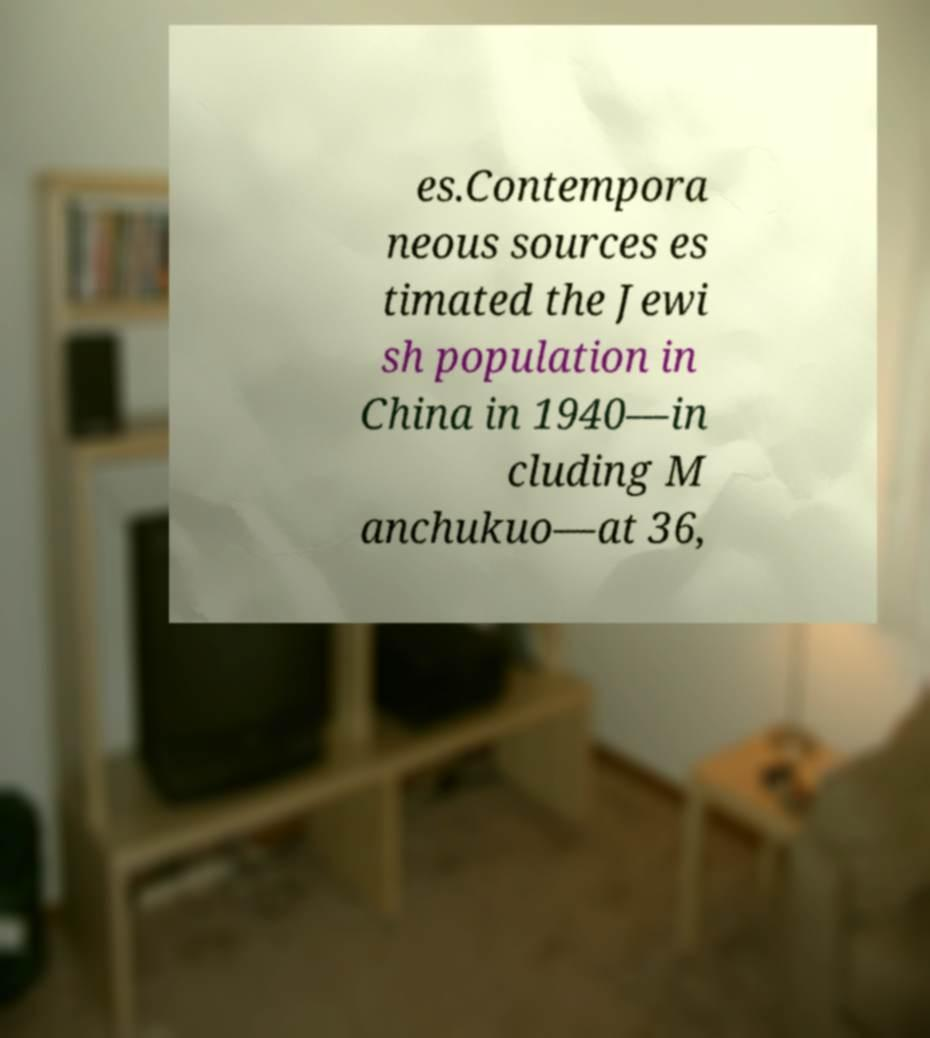Please read and relay the text visible in this image. What does it say? es.Contempora neous sources es timated the Jewi sh population in China in 1940—in cluding M anchukuo—at 36, 